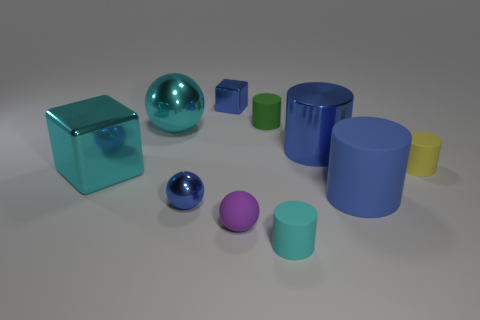Subtract all cyan cylinders. How many cylinders are left? 4 Subtract all green cylinders. How many cylinders are left? 4 Subtract all blocks. How many objects are left? 8 Subtract all purple cylinders. Subtract all green spheres. How many cylinders are left? 5 Subtract all large cylinders. Subtract all blue cylinders. How many objects are left? 6 Add 2 small shiny things. How many small shiny things are left? 4 Add 8 large cubes. How many large cubes exist? 9 Subtract 0 green cubes. How many objects are left? 10 